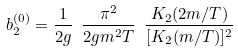Convert formula to latex. <formula><loc_0><loc_0><loc_500><loc_500>b _ { 2 } ^ { ( 0 ) } = \frac { 1 } { 2 g } \ \frac { \pi ^ { 2 } } { 2 g m ^ { 2 } T } \ \frac { K _ { 2 } ( 2 m / T ) } { [ K _ { 2 } ( m / T ) ] ^ { 2 } }</formula> 